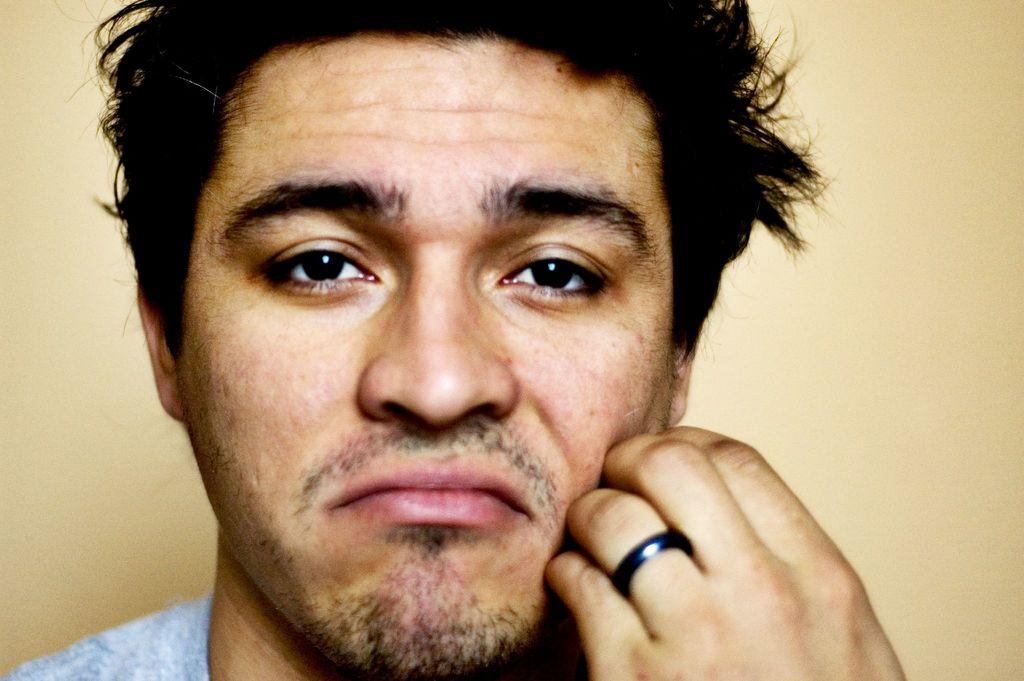What can be seen in the image? There is a person in the image. Can you describe the person's clothing? The person is wearing a grey t-shirt. What is the color of the person's hair? The person has black hair. Is there any jewelry visible on the person? Yes, the person has a ring on their left hand. What is visible in the background of the image? There is a wall in the background of the image. What type of plastic covers the person's horn in the image? There is no plastic or horn present in the image; it features a person wearing a grey t-shirt and a ring on their left hand. 